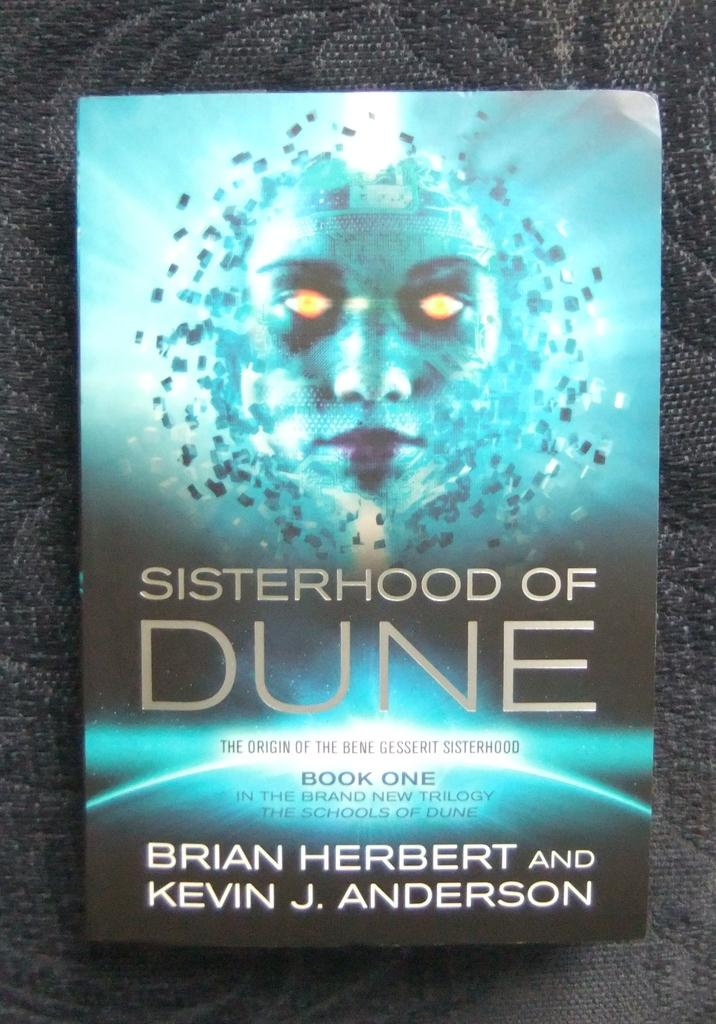Provide a one-sentence caption for the provided image. A book cover for Sisterhood of Dune features a face with glowing yellow eyes. 